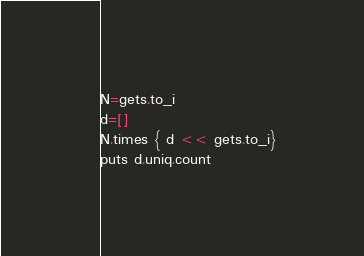Convert code to text. <code><loc_0><loc_0><loc_500><loc_500><_Ruby_>N=gets.to_i
d=[]
N.times { d << gets.to_i}
puts d.uniq.count</code> 